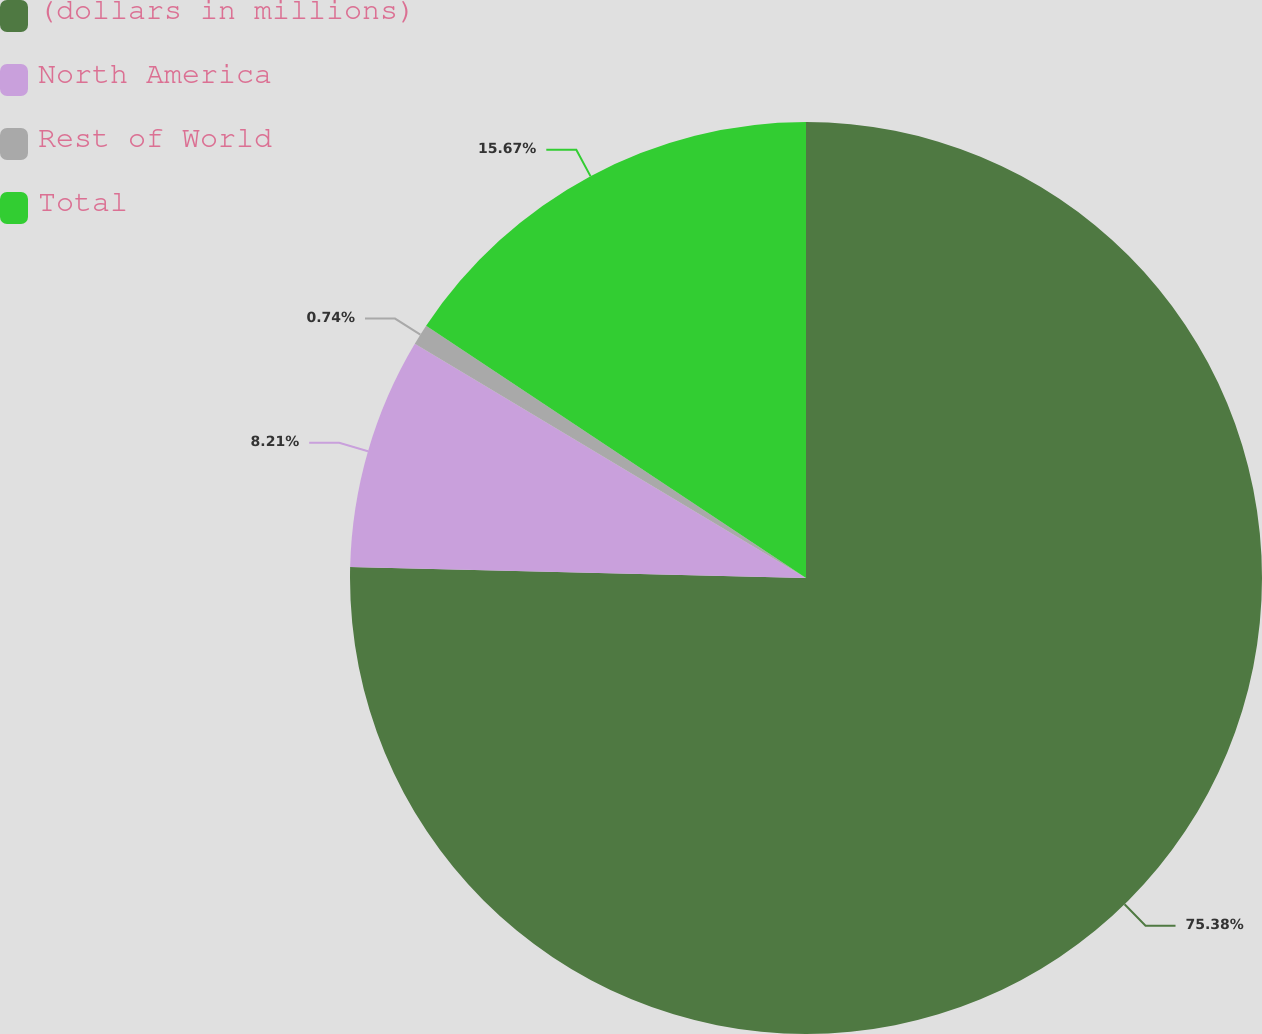<chart> <loc_0><loc_0><loc_500><loc_500><pie_chart><fcel>(dollars in millions)<fcel>North America<fcel>Rest of World<fcel>Total<nl><fcel>75.38%<fcel>8.21%<fcel>0.74%<fcel>15.67%<nl></chart> 